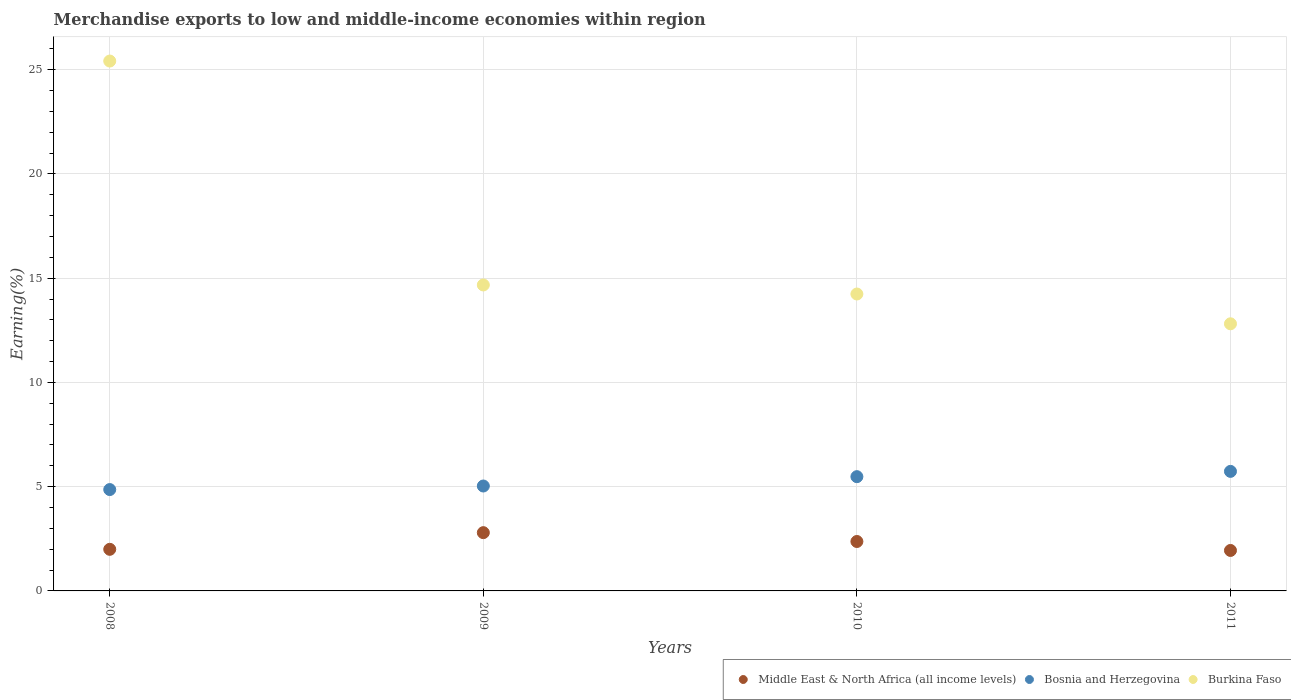How many different coloured dotlines are there?
Give a very brief answer. 3. Is the number of dotlines equal to the number of legend labels?
Make the answer very short. Yes. What is the percentage of amount earned from merchandise exports in Bosnia and Herzegovina in 2008?
Offer a terse response. 4.86. Across all years, what is the maximum percentage of amount earned from merchandise exports in Middle East & North Africa (all income levels)?
Give a very brief answer. 2.79. Across all years, what is the minimum percentage of amount earned from merchandise exports in Burkina Faso?
Your answer should be compact. 12.81. In which year was the percentage of amount earned from merchandise exports in Bosnia and Herzegovina minimum?
Your response must be concise. 2008. What is the total percentage of amount earned from merchandise exports in Burkina Faso in the graph?
Your answer should be compact. 67.14. What is the difference between the percentage of amount earned from merchandise exports in Bosnia and Herzegovina in 2010 and that in 2011?
Ensure brevity in your answer.  -0.25. What is the difference between the percentage of amount earned from merchandise exports in Bosnia and Herzegovina in 2010 and the percentage of amount earned from merchandise exports in Middle East & North Africa (all income levels) in 2009?
Keep it short and to the point. 2.69. What is the average percentage of amount earned from merchandise exports in Burkina Faso per year?
Ensure brevity in your answer.  16.79. In the year 2010, what is the difference between the percentage of amount earned from merchandise exports in Burkina Faso and percentage of amount earned from merchandise exports in Middle East & North Africa (all income levels)?
Your response must be concise. 11.87. In how many years, is the percentage of amount earned from merchandise exports in Middle East & North Africa (all income levels) greater than 11 %?
Ensure brevity in your answer.  0. What is the ratio of the percentage of amount earned from merchandise exports in Bosnia and Herzegovina in 2010 to that in 2011?
Offer a very short reply. 0.96. What is the difference between the highest and the second highest percentage of amount earned from merchandise exports in Burkina Faso?
Give a very brief answer. 10.74. What is the difference between the highest and the lowest percentage of amount earned from merchandise exports in Burkina Faso?
Your answer should be very brief. 12.6. In how many years, is the percentage of amount earned from merchandise exports in Bosnia and Herzegovina greater than the average percentage of amount earned from merchandise exports in Bosnia and Herzegovina taken over all years?
Provide a short and direct response. 2. Does the percentage of amount earned from merchandise exports in Burkina Faso monotonically increase over the years?
Give a very brief answer. No. How many dotlines are there?
Your response must be concise. 3. How many years are there in the graph?
Give a very brief answer. 4. What is the difference between two consecutive major ticks on the Y-axis?
Make the answer very short. 5. Where does the legend appear in the graph?
Your answer should be compact. Bottom right. How many legend labels are there?
Provide a succinct answer. 3. What is the title of the graph?
Ensure brevity in your answer.  Merchandise exports to low and middle-income economies within region. Does "Bolivia" appear as one of the legend labels in the graph?
Your answer should be compact. No. What is the label or title of the X-axis?
Offer a very short reply. Years. What is the label or title of the Y-axis?
Your answer should be very brief. Earning(%). What is the Earning(%) of Middle East & North Africa (all income levels) in 2008?
Offer a very short reply. 2. What is the Earning(%) in Bosnia and Herzegovina in 2008?
Ensure brevity in your answer.  4.86. What is the Earning(%) in Burkina Faso in 2008?
Make the answer very short. 25.41. What is the Earning(%) in Middle East & North Africa (all income levels) in 2009?
Your answer should be very brief. 2.79. What is the Earning(%) in Bosnia and Herzegovina in 2009?
Offer a very short reply. 5.03. What is the Earning(%) in Burkina Faso in 2009?
Keep it short and to the point. 14.67. What is the Earning(%) of Middle East & North Africa (all income levels) in 2010?
Give a very brief answer. 2.37. What is the Earning(%) in Bosnia and Herzegovina in 2010?
Ensure brevity in your answer.  5.48. What is the Earning(%) of Burkina Faso in 2010?
Provide a succinct answer. 14.24. What is the Earning(%) in Middle East & North Africa (all income levels) in 2011?
Provide a short and direct response. 1.94. What is the Earning(%) in Bosnia and Herzegovina in 2011?
Your answer should be compact. 5.73. What is the Earning(%) of Burkina Faso in 2011?
Make the answer very short. 12.81. Across all years, what is the maximum Earning(%) in Middle East & North Africa (all income levels)?
Ensure brevity in your answer.  2.79. Across all years, what is the maximum Earning(%) of Bosnia and Herzegovina?
Your answer should be compact. 5.73. Across all years, what is the maximum Earning(%) in Burkina Faso?
Your answer should be compact. 25.41. Across all years, what is the minimum Earning(%) of Middle East & North Africa (all income levels)?
Your answer should be very brief. 1.94. Across all years, what is the minimum Earning(%) of Bosnia and Herzegovina?
Ensure brevity in your answer.  4.86. Across all years, what is the minimum Earning(%) of Burkina Faso?
Your answer should be compact. 12.81. What is the total Earning(%) of Middle East & North Africa (all income levels) in the graph?
Your answer should be very brief. 9.1. What is the total Earning(%) of Bosnia and Herzegovina in the graph?
Your response must be concise. 21.11. What is the total Earning(%) in Burkina Faso in the graph?
Your answer should be very brief. 67.14. What is the difference between the Earning(%) in Middle East & North Africa (all income levels) in 2008 and that in 2009?
Make the answer very short. -0.8. What is the difference between the Earning(%) of Bosnia and Herzegovina in 2008 and that in 2009?
Make the answer very short. -0.17. What is the difference between the Earning(%) of Burkina Faso in 2008 and that in 2009?
Make the answer very short. 10.74. What is the difference between the Earning(%) of Middle East & North Africa (all income levels) in 2008 and that in 2010?
Your response must be concise. -0.38. What is the difference between the Earning(%) in Bosnia and Herzegovina in 2008 and that in 2010?
Your answer should be very brief. -0.62. What is the difference between the Earning(%) in Burkina Faso in 2008 and that in 2010?
Your answer should be very brief. 11.17. What is the difference between the Earning(%) in Middle East & North Africa (all income levels) in 2008 and that in 2011?
Offer a terse response. 0.05. What is the difference between the Earning(%) in Bosnia and Herzegovina in 2008 and that in 2011?
Make the answer very short. -0.87. What is the difference between the Earning(%) in Burkina Faso in 2008 and that in 2011?
Keep it short and to the point. 12.6. What is the difference between the Earning(%) of Middle East & North Africa (all income levels) in 2009 and that in 2010?
Your response must be concise. 0.42. What is the difference between the Earning(%) of Bosnia and Herzegovina in 2009 and that in 2010?
Your answer should be very brief. -0.45. What is the difference between the Earning(%) of Burkina Faso in 2009 and that in 2010?
Offer a very short reply. 0.43. What is the difference between the Earning(%) in Middle East & North Africa (all income levels) in 2009 and that in 2011?
Make the answer very short. 0.85. What is the difference between the Earning(%) of Bosnia and Herzegovina in 2009 and that in 2011?
Your response must be concise. -0.7. What is the difference between the Earning(%) in Burkina Faso in 2009 and that in 2011?
Provide a succinct answer. 1.86. What is the difference between the Earning(%) in Middle East & North Africa (all income levels) in 2010 and that in 2011?
Your response must be concise. 0.43. What is the difference between the Earning(%) in Bosnia and Herzegovina in 2010 and that in 2011?
Offer a terse response. -0.25. What is the difference between the Earning(%) in Burkina Faso in 2010 and that in 2011?
Offer a very short reply. 1.43. What is the difference between the Earning(%) in Middle East & North Africa (all income levels) in 2008 and the Earning(%) in Bosnia and Herzegovina in 2009?
Your response must be concise. -3.04. What is the difference between the Earning(%) of Middle East & North Africa (all income levels) in 2008 and the Earning(%) of Burkina Faso in 2009?
Offer a terse response. -12.68. What is the difference between the Earning(%) of Bosnia and Herzegovina in 2008 and the Earning(%) of Burkina Faso in 2009?
Provide a short and direct response. -9.81. What is the difference between the Earning(%) in Middle East & North Africa (all income levels) in 2008 and the Earning(%) in Bosnia and Herzegovina in 2010?
Keep it short and to the point. -3.48. What is the difference between the Earning(%) of Middle East & North Africa (all income levels) in 2008 and the Earning(%) of Burkina Faso in 2010?
Provide a succinct answer. -12.25. What is the difference between the Earning(%) in Bosnia and Herzegovina in 2008 and the Earning(%) in Burkina Faso in 2010?
Ensure brevity in your answer.  -9.38. What is the difference between the Earning(%) in Middle East & North Africa (all income levels) in 2008 and the Earning(%) in Bosnia and Herzegovina in 2011?
Ensure brevity in your answer.  -3.74. What is the difference between the Earning(%) of Middle East & North Africa (all income levels) in 2008 and the Earning(%) of Burkina Faso in 2011?
Offer a terse response. -10.82. What is the difference between the Earning(%) in Bosnia and Herzegovina in 2008 and the Earning(%) in Burkina Faso in 2011?
Ensure brevity in your answer.  -7.95. What is the difference between the Earning(%) of Middle East & North Africa (all income levels) in 2009 and the Earning(%) of Bosnia and Herzegovina in 2010?
Provide a short and direct response. -2.69. What is the difference between the Earning(%) of Middle East & North Africa (all income levels) in 2009 and the Earning(%) of Burkina Faso in 2010?
Make the answer very short. -11.45. What is the difference between the Earning(%) in Bosnia and Herzegovina in 2009 and the Earning(%) in Burkina Faso in 2010?
Give a very brief answer. -9.21. What is the difference between the Earning(%) in Middle East & North Africa (all income levels) in 2009 and the Earning(%) in Bosnia and Herzegovina in 2011?
Your response must be concise. -2.94. What is the difference between the Earning(%) in Middle East & North Africa (all income levels) in 2009 and the Earning(%) in Burkina Faso in 2011?
Your answer should be very brief. -10.02. What is the difference between the Earning(%) of Bosnia and Herzegovina in 2009 and the Earning(%) of Burkina Faso in 2011?
Offer a very short reply. -7.78. What is the difference between the Earning(%) of Middle East & North Africa (all income levels) in 2010 and the Earning(%) of Bosnia and Herzegovina in 2011?
Make the answer very short. -3.36. What is the difference between the Earning(%) of Middle East & North Africa (all income levels) in 2010 and the Earning(%) of Burkina Faso in 2011?
Offer a very short reply. -10.44. What is the difference between the Earning(%) of Bosnia and Herzegovina in 2010 and the Earning(%) of Burkina Faso in 2011?
Keep it short and to the point. -7.33. What is the average Earning(%) of Middle East & North Africa (all income levels) per year?
Your answer should be very brief. 2.28. What is the average Earning(%) of Bosnia and Herzegovina per year?
Your response must be concise. 5.28. What is the average Earning(%) of Burkina Faso per year?
Make the answer very short. 16.79. In the year 2008, what is the difference between the Earning(%) in Middle East & North Africa (all income levels) and Earning(%) in Bosnia and Herzegovina?
Make the answer very short. -2.87. In the year 2008, what is the difference between the Earning(%) in Middle East & North Africa (all income levels) and Earning(%) in Burkina Faso?
Ensure brevity in your answer.  -23.42. In the year 2008, what is the difference between the Earning(%) in Bosnia and Herzegovina and Earning(%) in Burkina Faso?
Your answer should be very brief. -20.55. In the year 2009, what is the difference between the Earning(%) in Middle East & North Africa (all income levels) and Earning(%) in Bosnia and Herzegovina?
Your response must be concise. -2.24. In the year 2009, what is the difference between the Earning(%) of Middle East & North Africa (all income levels) and Earning(%) of Burkina Faso?
Your answer should be compact. -11.88. In the year 2009, what is the difference between the Earning(%) in Bosnia and Herzegovina and Earning(%) in Burkina Faso?
Your answer should be very brief. -9.64. In the year 2010, what is the difference between the Earning(%) of Middle East & North Africa (all income levels) and Earning(%) of Bosnia and Herzegovina?
Offer a terse response. -3.11. In the year 2010, what is the difference between the Earning(%) of Middle East & North Africa (all income levels) and Earning(%) of Burkina Faso?
Keep it short and to the point. -11.87. In the year 2010, what is the difference between the Earning(%) in Bosnia and Herzegovina and Earning(%) in Burkina Faso?
Provide a succinct answer. -8.76. In the year 2011, what is the difference between the Earning(%) in Middle East & North Africa (all income levels) and Earning(%) in Bosnia and Herzegovina?
Provide a short and direct response. -3.79. In the year 2011, what is the difference between the Earning(%) in Middle East & North Africa (all income levels) and Earning(%) in Burkina Faso?
Offer a terse response. -10.87. In the year 2011, what is the difference between the Earning(%) in Bosnia and Herzegovina and Earning(%) in Burkina Faso?
Your answer should be very brief. -7.08. What is the ratio of the Earning(%) in Middle East & North Africa (all income levels) in 2008 to that in 2009?
Your answer should be compact. 0.71. What is the ratio of the Earning(%) of Bosnia and Herzegovina in 2008 to that in 2009?
Keep it short and to the point. 0.97. What is the ratio of the Earning(%) of Burkina Faso in 2008 to that in 2009?
Keep it short and to the point. 1.73. What is the ratio of the Earning(%) of Middle East & North Africa (all income levels) in 2008 to that in 2010?
Give a very brief answer. 0.84. What is the ratio of the Earning(%) of Bosnia and Herzegovina in 2008 to that in 2010?
Ensure brevity in your answer.  0.89. What is the ratio of the Earning(%) in Burkina Faso in 2008 to that in 2010?
Provide a short and direct response. 1.78. What is the ratio of the Earning(%) in Middle East & North Africa (all income levels) in 2008 to that in 2011?
Give a very brief answer. 1.03. What is the ratio of the Earning(%) in Bosnia and Herzegovina in 2008 to that in 2011?
Offer a very short reply. 0.85. What is the ratio of the Earning(%) in Burkina Faso in 2008 to that in 2011?
Your answer should be very brief. 1.98. What is the ratio of the Earning(%) of Middle East & North Africa (all income levels) in 2009 to that in 2010?
Provide a short and direct response. 1.18. What is the ratio of the Earning(%) of Bosnia and Herzegovina in 2009 to that in 2010?
Provide a short and direct response. 0.92. What is the ratio of the Earning(%) of Burkina Faso in 2009 to that in 2010?
Provide a short and direct response. 1.03. What is the ratio of the Earning(%) in Middle East & North Africa (all income levels) in 2009 to that in 2011?
Keep it short and to the point. 1.44. What is the ratio of the Earning(%) of Bosnia and Herzegovina in 2009 to that in 2011?
Your response must be concise. 0.88. What is the ratio of the Earning(%) of Burkina Faso in 2009 to that in 2011?
Offer a very short reply. 1.15. What is the ratio of the Earning(%) in Middle East & North Africa (all income levels) in 2010 to that in 2011?
Offer a very short reply. 1.22. What is the ratio of the Earning(%) in Bosnia and Herzegovina in 2010 to that in 2011?
Make the answer very short. 0.96. What is the ratio of the Earning(%) of Burkina Faso in 2010 to that in 2011?
Provide a succinct answer. 1.11. What is the difference between the highest and the second highest Earning(%) of Middle East & North Africa (all income levels)?
Provide a succinct answer. 0.42. What is the difference between the highest and the second highest Earning(%) of Bosnia and Herzegovina?
Provide a succinct answer. 0.25. What is the difference between the highest and the second highest Earning(%) in Burkina Faso?
Offer a terse response. 10.74. What is the difference between the highest and the lowest Earning(%) of Middle East & North Africa (all income levels)?
Ensure brevity in your answer.  0.85. What is the difference between the highest and the lowest Earning(%) of Bosnia and Herzegovina?
Offer a very short reply. 0.87. What is the difference between the highest and the lowest Earning(%) of Burkina Faso?
Give a very brief answer. 12.6. 